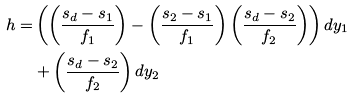Convert formula to latex. <formula><loc_0><loc_0><loc_500><loc_500>h = & \left ( \left ( \frac { s _ { d } - s _ { 1 } } { f _ { 1 } } \right ) - \left ( \frac { s _ { 2 } - s _ { 1 } } { f _ { 1 } } \right ) \left ( \frac { s _ { d } - s _ { 2 } } { f _ { 2 } } \right ) \right ) d y _ { 1 } \\ & + \left ( \frac { s _ { d } - s _ { 2 } } { f _ { 2 } } \right ) d y _ { 2 }</formula> 